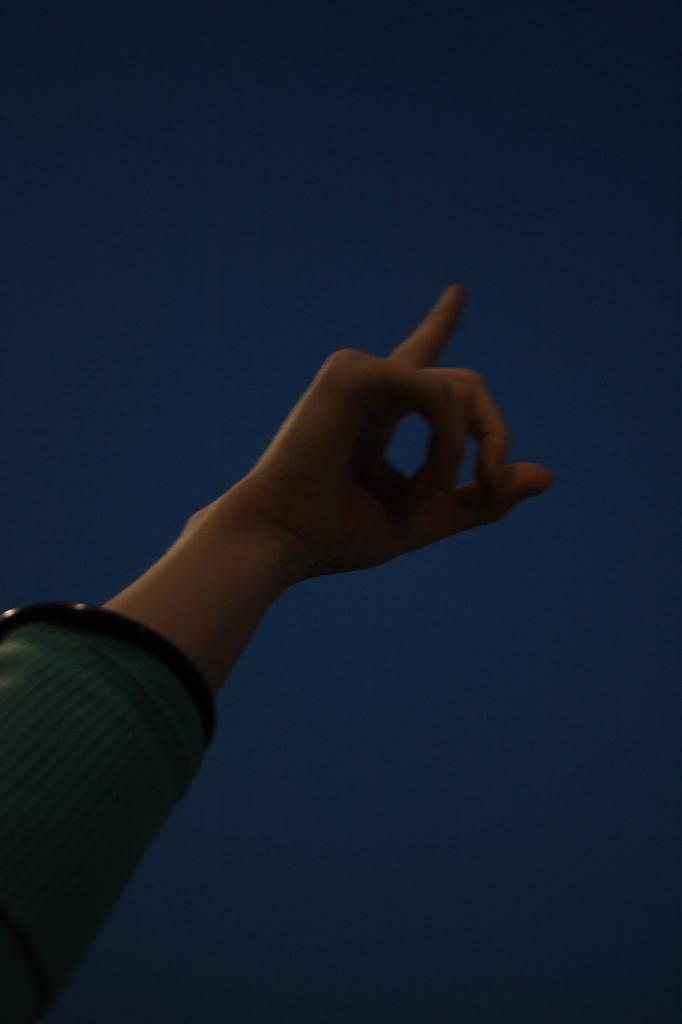What is the main subject of the image? The main subject of the image is the hand of a person. What can be seen in the background of the image? The background of the image is blue in color. What type of toys can be seen in the image? There are no toys present in the image; it only features the hand of a person against a blue background. 